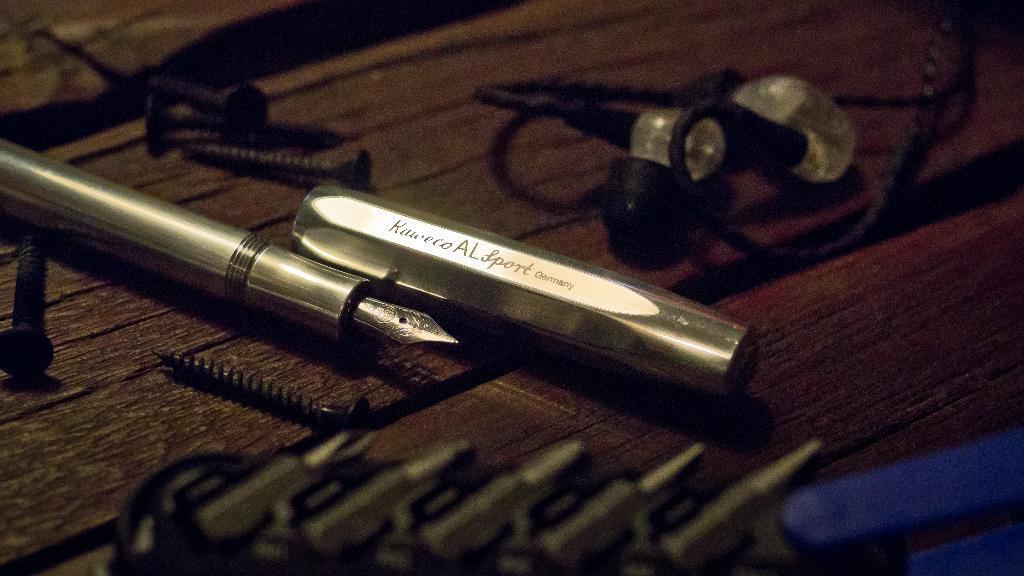How would you summarize this image in a sentence or two? In this picture we can see a pen, screws and few objects and these all are placed on the wooden platform. 